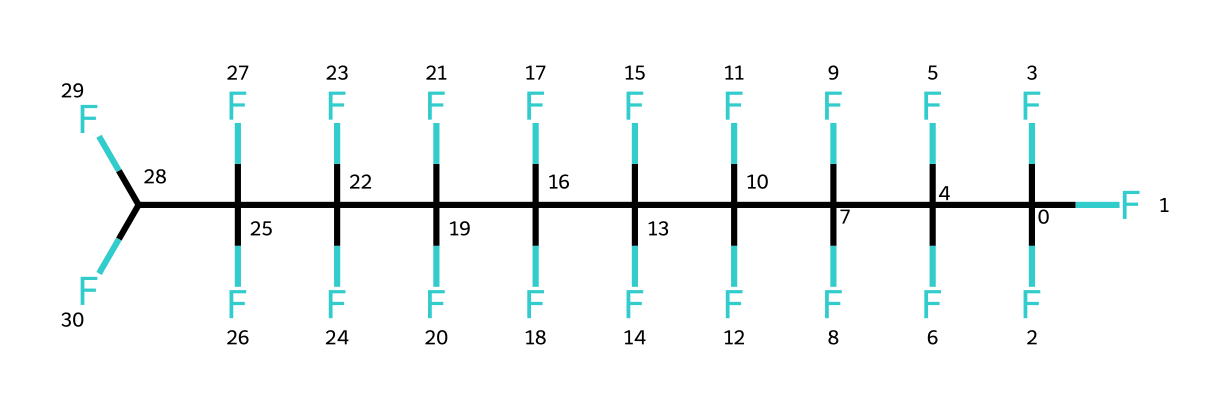What is the chemical name of the compound represented by the given SMILES? The SMILES structure indicates a chain of carbon atoms fully substituted with fluorine atoms. This arrangement corresponds to polytetrafluoroethylene (PTFE), commonly known as Teflon.
Answer: polytetrafluoroethylene How many carbon atoms are present in the structure? By analyzing the SMILES notation, we can count the distinct carbon atoms which appear as the "C" symbols. In total, there are 10 carbon atoms included in this structure.
Answer: 10 What kind of bonding characterizes the C-F bonds in this compound? The bonds between carbon and fluorine in fluoropolymers are strong covalent bonds due to the high electronegativity of fluorine compared to carbon, leading to significant polarity.
Answer: covalent How many fluorine atoms are attached to each carbon atom? By examining the structure, we can see each carbon atom is surrounded by three fluorine atoms, indicating that each carbon has three attachments of fluorine.
Answer: three What is the primary property of fluoropolymers that makes them suitable for non-stick coatings? The presence of multiple fluorine atoms creates a low surface energy and non-reactive nature, leading to their non-stick characteristics that are essential for coatings.
Answer: non-stick What is the impact of the high electronegativity of fluorine on this compound? The high electronegativity of fluorine enhances the bond strength and contributes to the overall chemical stability and resistance to chemical degradation, making the polymers durable.
Answer: stability 